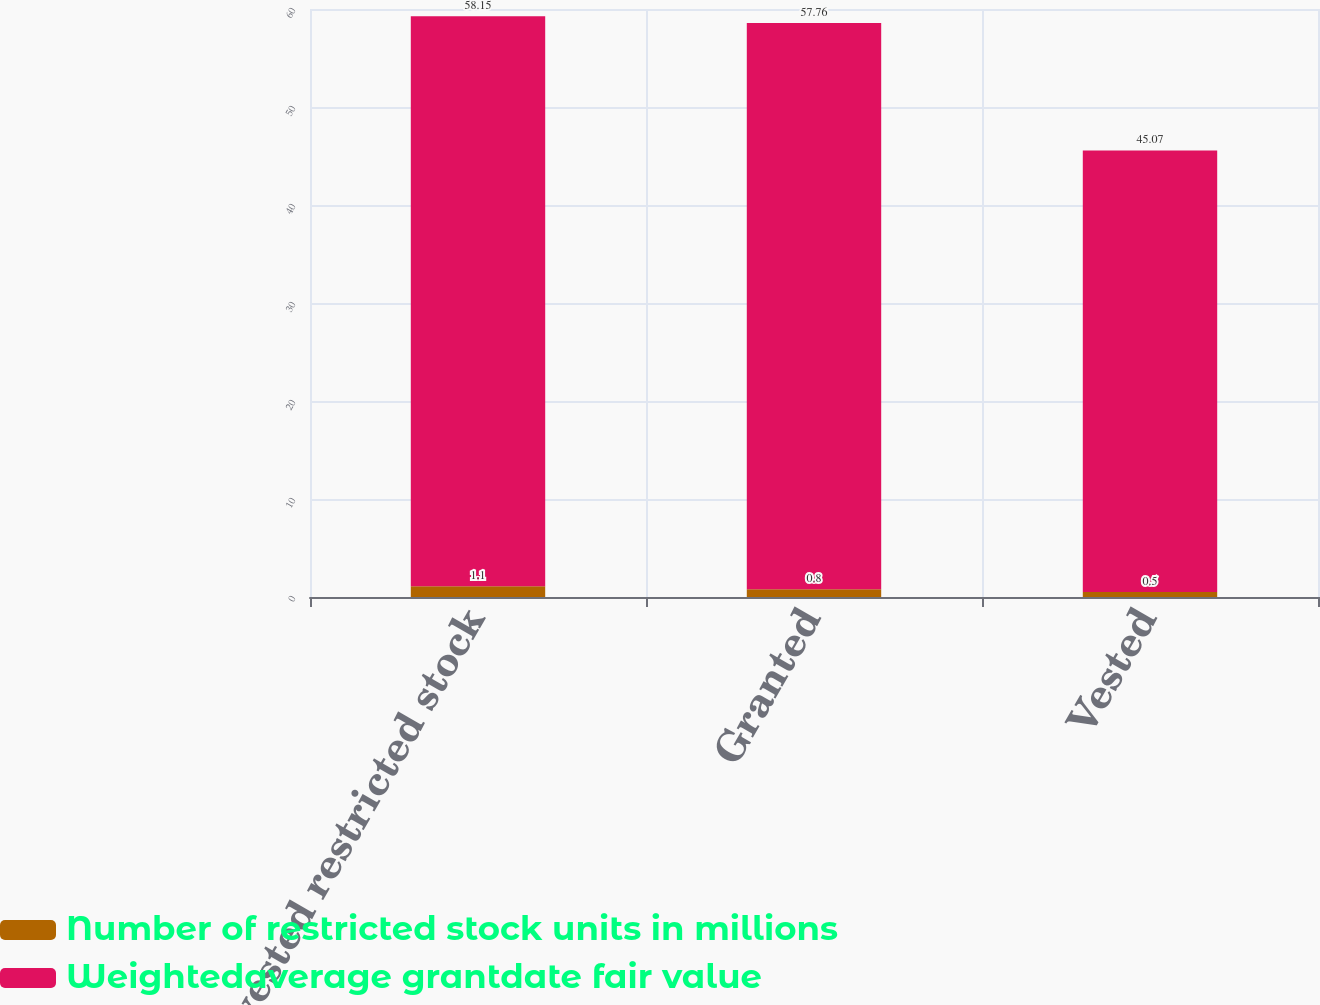Convert chart to OTSL. <chart><loc_0><loc_0><loc_500><loc_500><stacked_bar_chart><ecel><fcel>Nonvested restricted stock<fcel>Granted<fcel>Vested<nl><fcel>Number of restricted stock units in millions<fcel>1.1<fcel>0.8<fcel>0.5<nl><fcel>Weightedaverage grantdate fair value<fcel>58.15<fcel>57.76<fcel>45.07<nl></chart> 